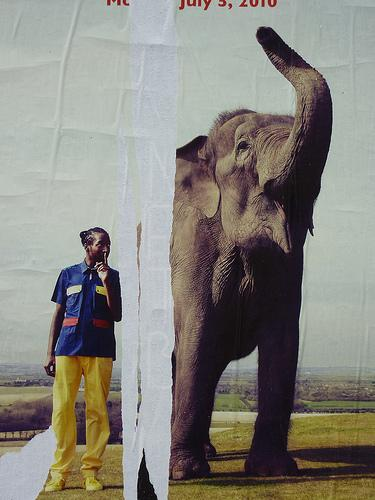What is an accessory that the man is wearing in the image, and what color is it? The man is wearing yellow sneakers with yellow shoe laces. What kind of animal is featured prominently in the image, and what color is it? The image prominently features a large grey elephant on grass. Provide a detailed summary of the details of the man's attire in the image. The man is wearing a blue short sleeve shirt with four pockets, yellow and red flaps, and yellow pants that have wrinkles, along with yellow sneakers. Describe the interaction between the man and the elephant in the image. The man is standing beside the elephant on grass, and the elephant has its mouth open and trunk raised. What are two activities the elephant is doing in the image? The elephant is opening its mouth and raising its trunk in the air. Please enumerate some distinctive features of the man's shirt. The man's shirt is blue, short-sleeved, and has four pockets with yellow tops and red flaps. What is the color of the writing in the image and on what surface is it written? The writing is in red and on white paper. Discuss the state of the writing in the image and mention any possible issue with it. The writing is in red but is cut off, and it appears that the date was written in the image. State the condition of the trees and some visible damage in the image. The trees are bare of leaves, and the picture was damaged in the middle. Identify the primary colors of the clothing of the man in the image. The man is wearing a blue shirt and yellow pants with yellow shoes. 